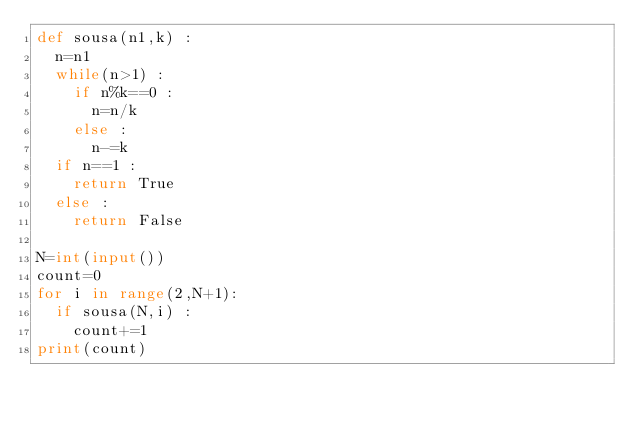Convert code to text. <code><loc_0><loc_0><loc_500><loc_500><_Python_>def sousa(n1,k) :
  n=n1
  while(n>1) :
    if n%k==0 :
      n=n/k
    else :
      n-=k
  if n==1 :
    return True
  else :
    return False
  
N=int(input())
count=0
for i in range(2,N+1):
  if sousa(N,i) :
    count+=1
print(count)</code> 